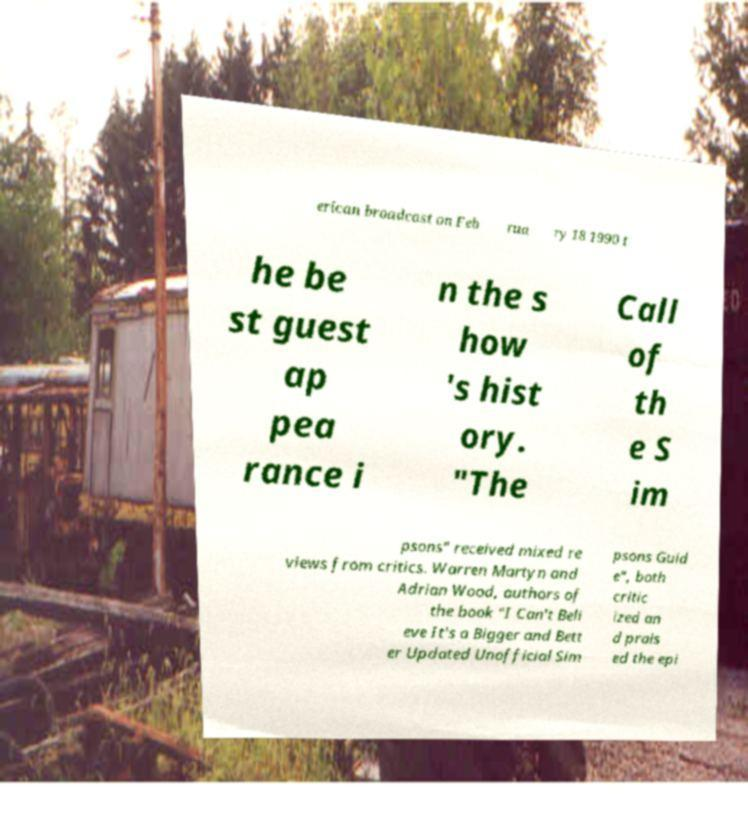For documentation purposes, I need the text within this image transcribed. Could you provide that? erican broadcast on Feb rua ry 18 1990 t he be st guest ap pea rance i n the s how 's hist ory. "The Call of th e S im psons" received mixed re views from critics. Warren Martyn and Adrian Wood, authors of the book "I Can't Beli eve It's a Bigger and Bett er Updated Unofficial Sim psons Guid e", both critic ized an d prais ed the epi 